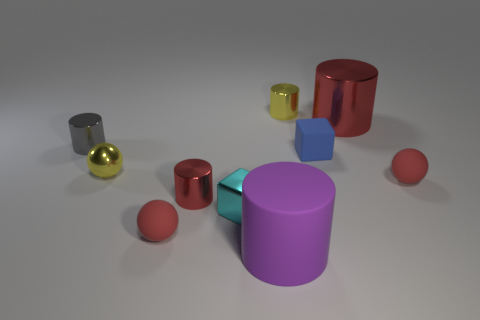How many things are either small metal objects behind the tiny gray cylinder or matte balls?
Offer a terse response. 3. What number of other objects are the same color as the tiny metallic sphere?
Offer a very short reply. 1. Are there the same number of large red cylinders that are in front of the yellow sphere and small red matte cylinders?
Your answer should be compact. Yes. There is a small metal cylinder that is in front of the small sphere that is on the right side of the small yellow cylinder; how many small things are on the left side of it?
Keep it short and to the point. 3. There is a yellow shiny cylinder; is it the same size as the red ball that is to the left of the yellow shiny cylinder?
Give a very brief answer. Yes. How many large purple matte objects are there?
Give a very brief answer. 1. There is a yellow metal object that is behind the small blue matte cube; is it the same size as the red metallic cylinder that is behind the gray thing?
Offer a terse response. No. What color is the big matte object that is the same shape as the tiny gray metallic object?
Provide a short and direct response. Purple. Do the tiny red shiny object and the small gray thing have the same shape?
Your response must be concise. Yes. The yellow metal thing that is the same shape as the purple matte thing is what size?
Offer a very short reply. Small. 